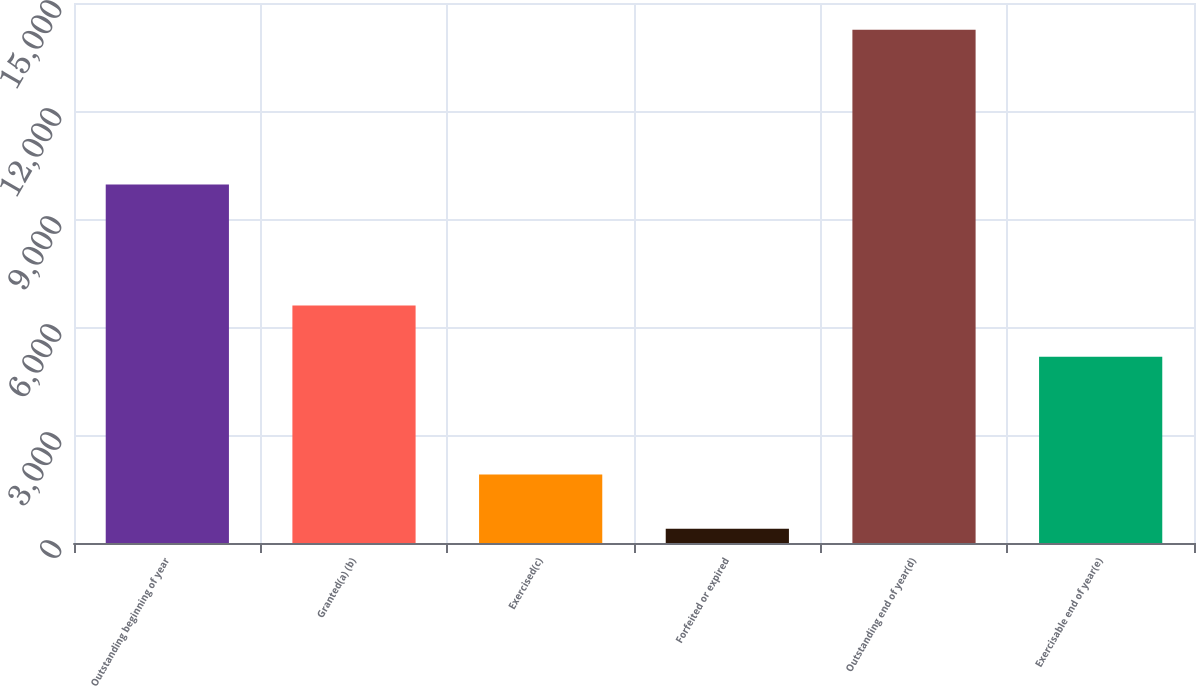Convert chart. <chart><loc_0><loc_0><loc_500><loc_500><bar_chart><fcel>Outstanding beginning of year<fcel>Granted(a) (b)<fcel>Exercised(c)<fcel>Forfeited or expired<fcel>Outstanding end of year(d)<fcel>Exercisable end of year(e)<nl><fcel>9957<fcel>6597<fcel>1900<fcel>399<fcel>14255<fcel>5176<nl></chart> 